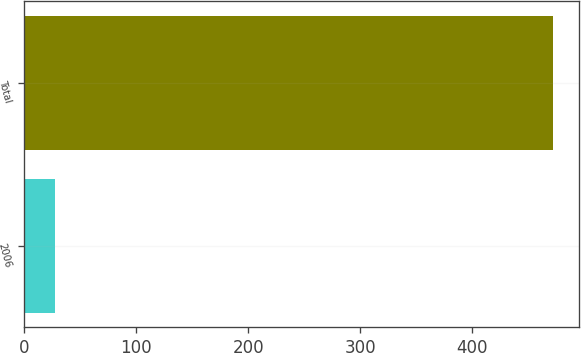Convert chart to OTSL. <chart><loc_0><loc_0><loc_500><loc_500><bar_chart><fcel>2006<fcel>Total<nl><fcel>27<fcel>472.3<nl></chart> 